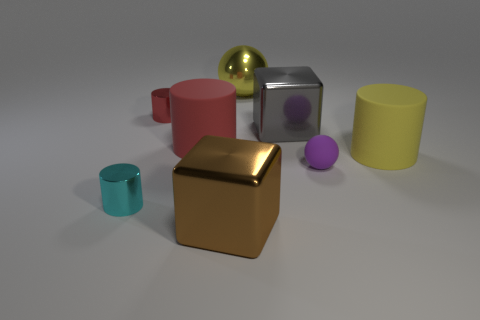Subtract all tiny red cylinders. How many cylinders are left? 3 Subtract all blocks. How many objects are left? 6 Subtract 2 cylinders. How many cylinders are left? 2 Subtract all blue cylinders. Subtract all gray balls. How many cylinders are left? 4 Subtract all gray cylinders. How many purple cubes are left? 0 Subtract all brown objects. Subtract all brown metallic objects. How many objects are left? 6 Add 5 gray things. How many gray things are left? 6 Add 3 big brown shiny objects. How many big brown shiny objects exist? 4 Add 2 brown metallic cubes. How many objects exist? 10 Subtract all yellow cylinders. How many cylinders are left? 3 